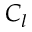<formula> <loc_0><loc_0><loc_500><loc_500>C _ { l }</formula> 